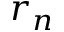Convert formula to latex. <formula><loc_0><loc_0><loc_500><loc_500>r _ { n }</formula> 